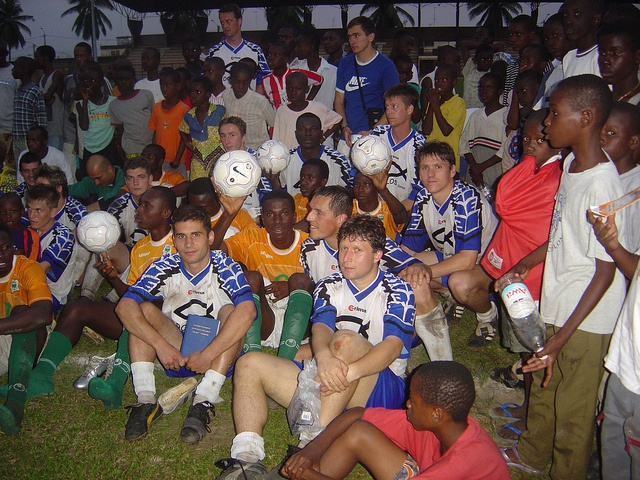Describe the objects in this image and their specific colors. I can see people in black, olive, gray, and maroon tones, people in black, olive, maroon, and lightgray tones, people in black, tan, gray, and lightgray tones, people in black, gray, lightgray, and darkgray tones, and people in black, maroon, and brown tones in this image. 